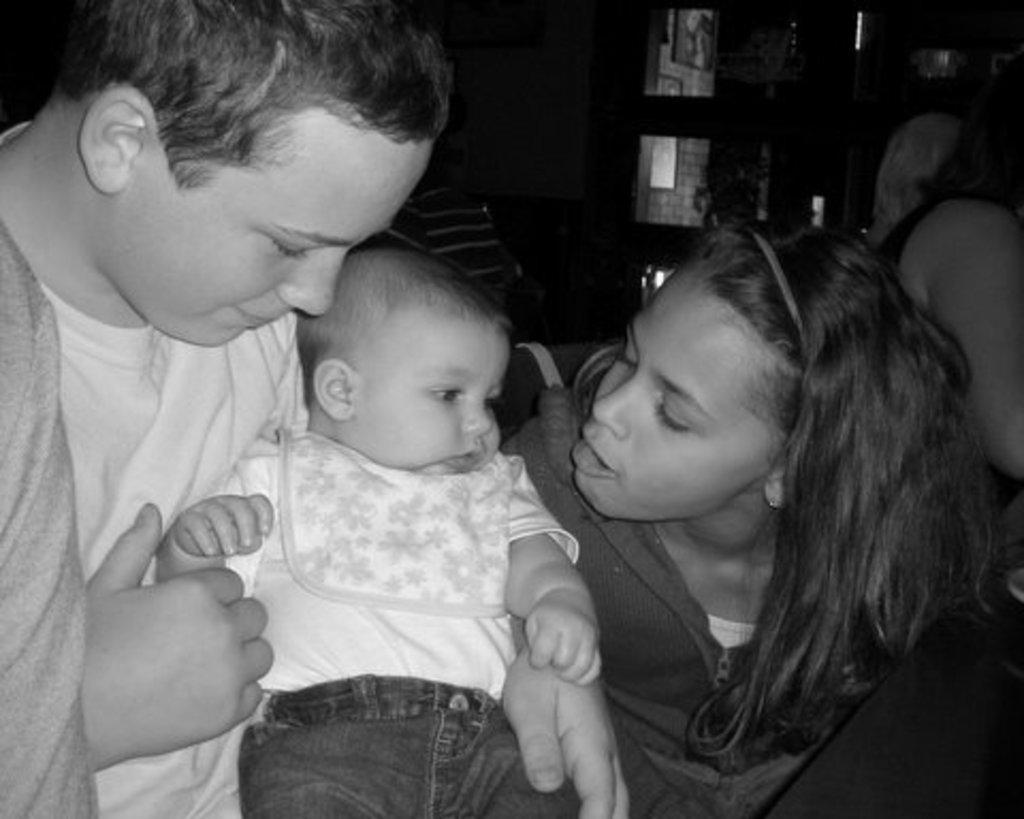Can you describe this image briefly? Here a boy is holding the baby, on the right side a girl is talking with the baby. 